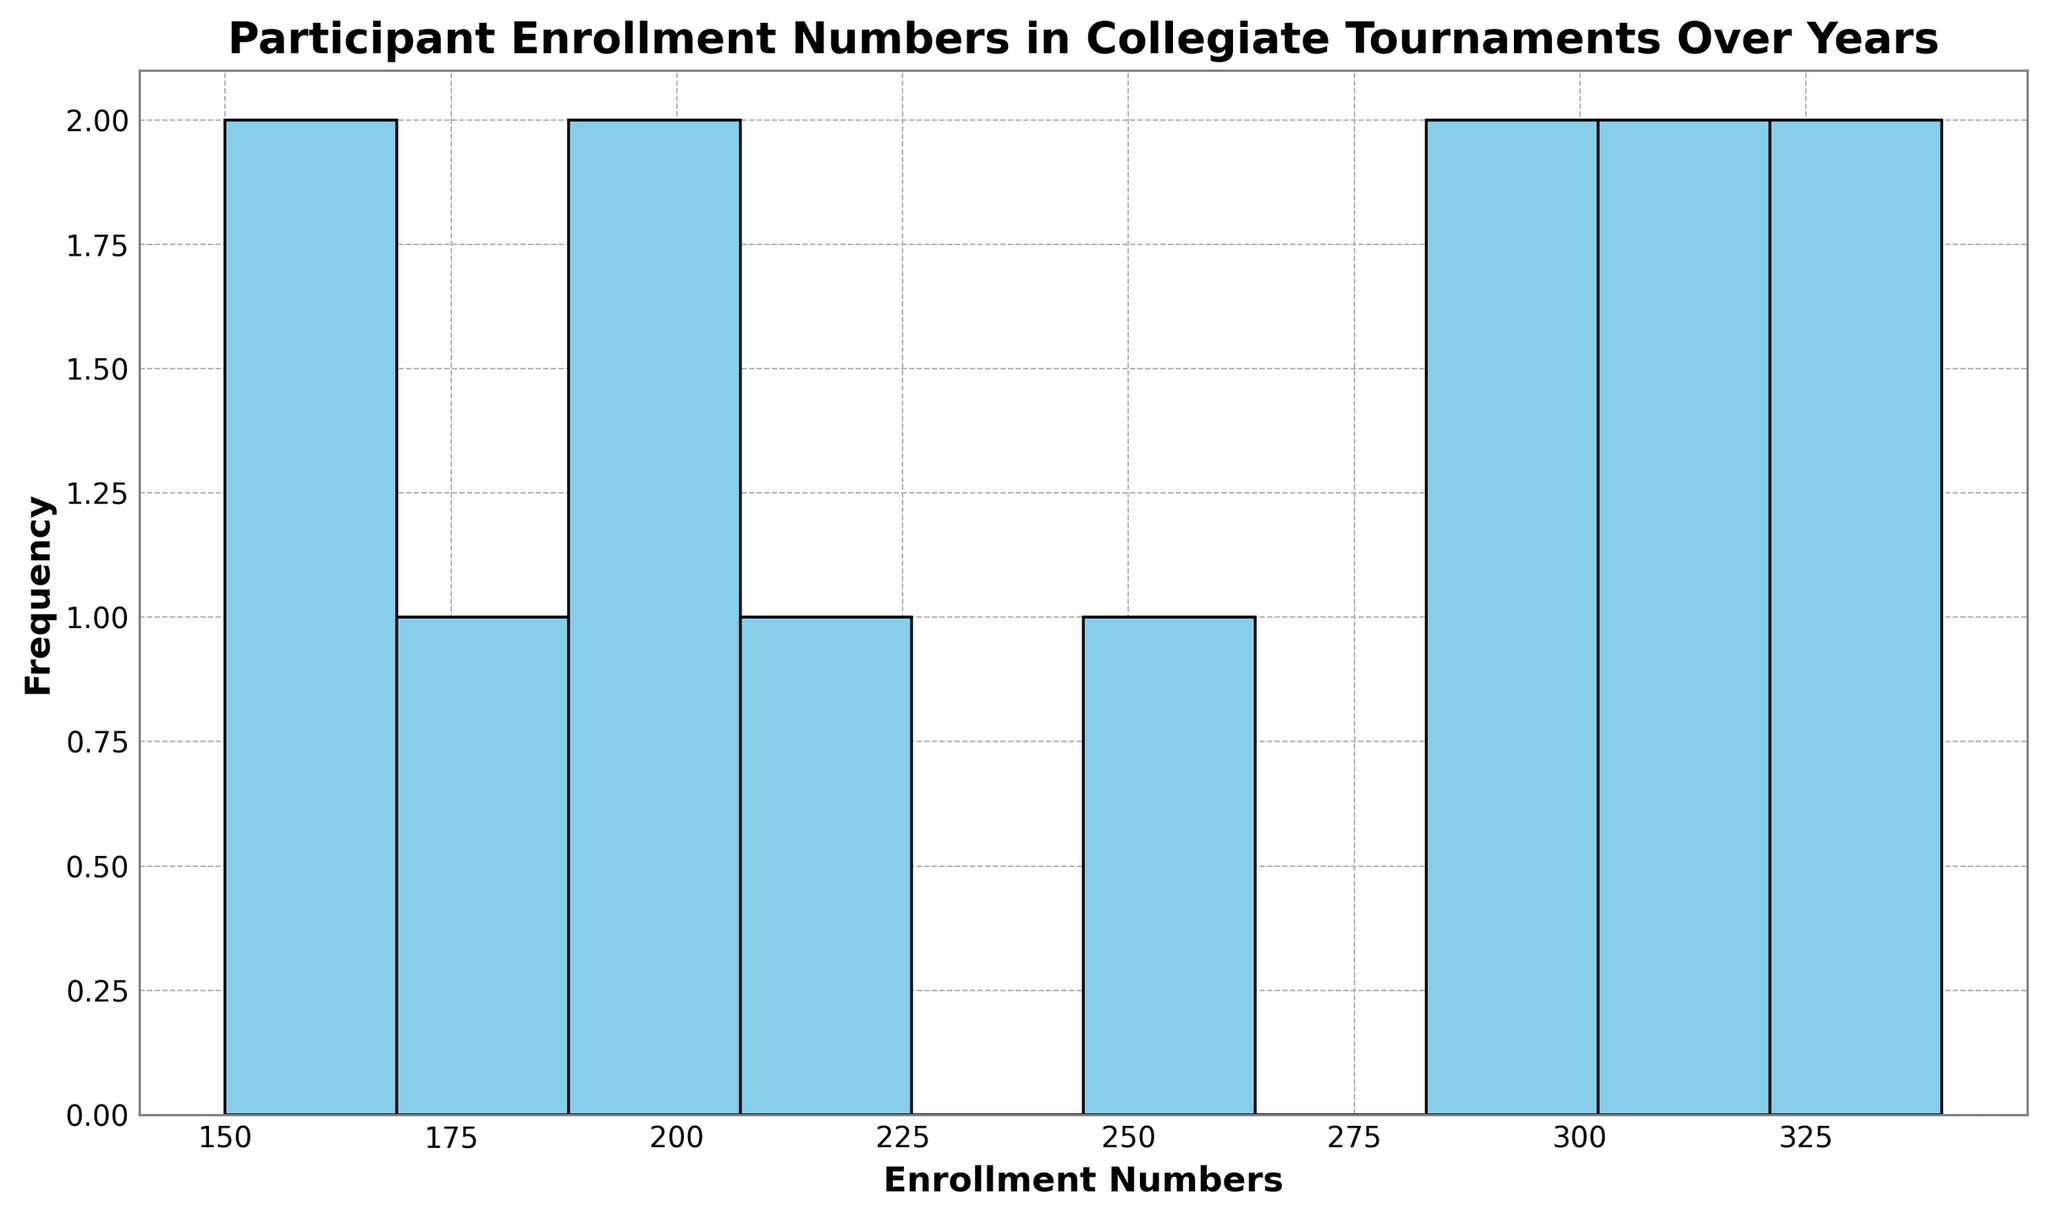Which year had the highest participant enrollment? Look at the histogram and identify the bar representing the highest enrollment number. Then find the corresponding year for that value from the data.
Answer: 2019 What is the range of participant enrollment numbers shown in the histogram? Determine the smallest and largest enrollment values displayed in the histogram. The range is the difference between these two values.
Answer: 150 to 340 How many years had an enrollment number greater than 300? Identify the bins on the histogram that include values greater than 300, then count the corresponding years from the data.
Answer: 4 Are there more years with an enrollment number below 200 or 250? Count the bars in the histogram that represent enrollment numbers below 200 and below 250, then compare the two counts.
Answer: Below 200 What is the most common enrollment number range in the histogram? Determine which bin in the histogram has the tallest bar, indicating the highest frequency. This bin represents the most common enrollment number range.
Answer: 300 - 350 By how much did the enrollment number decrease between 2019 and 2020? Subtract the enrollment number of 2020 from that of 2019 based on the data provided.
Answer: 50 What is the median participant enrollment number? Since there are 13 years, the median will be the enrollment number of the 7th year when data is sorted in ascending order. Identify this value in the dataset.
Answer: 250 Which year had the lowest participant enrollment? Find the bar representing the lowest enrollment value in the histogram, and check the corresponding year from the data.
Answer: 2010 How many bins does the histogram have? Count the number of bins represented in the histogram, usually identified by the number of distinct bars.
Answer: 10 What color are the bars in the histogram? Identify the color used for the bars by examining the visual representation of the histogram.
Answer: Skyblue 